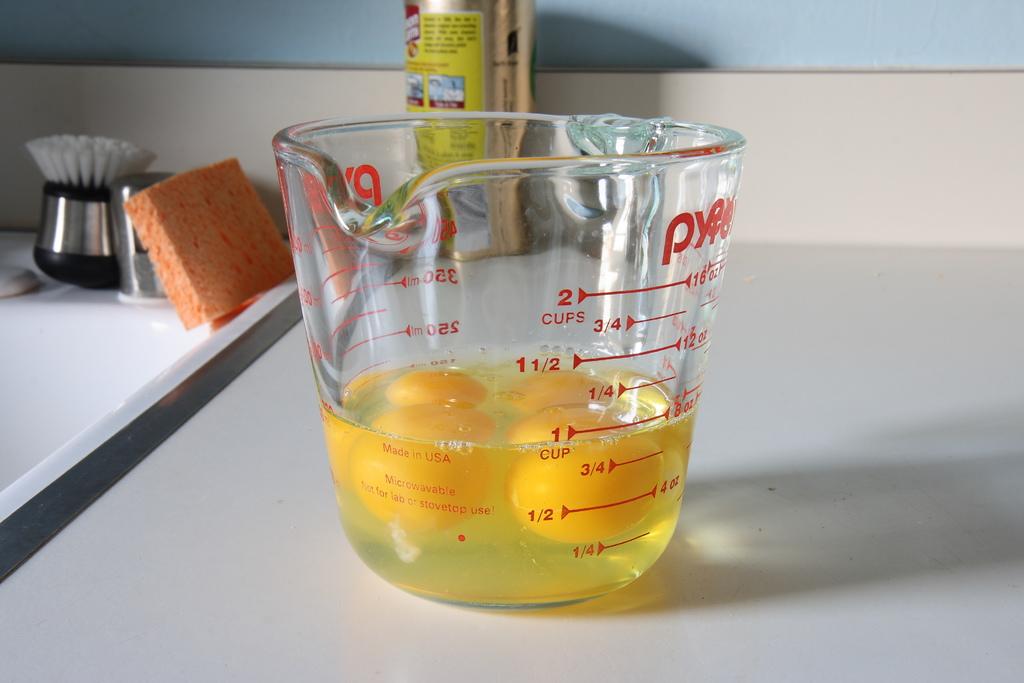How many cups does this measuring cup hold?
Give a very brief answer. 2. 